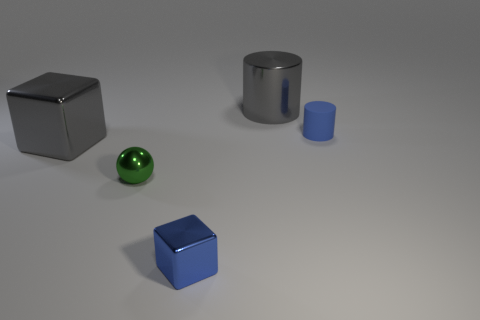Add 4 green balls. How many objects exist? 9 Subtract 1 blocks. How many blocks are left? 1 Subtract all blocks. How many objects are left? 3 Subtract all tiny cyan metallic cylinders. Subtract all blue cylinders. How many objects are left? 4 Add 5 large blocks. How many large blocks are left? 6 Add 2 large cyan metallic objects. How many large cyan metallic objects exist? 2 Subtract all gray cubes. How many cubes are left? 1 Subtract 0 cyan spheres. How many objects are left? 5 Subtract all gray cylinders. Subtract all blue spheres. How many cylinders are left? 1 Subtract all gray spheres. How many yellow cylinders are left? 0 